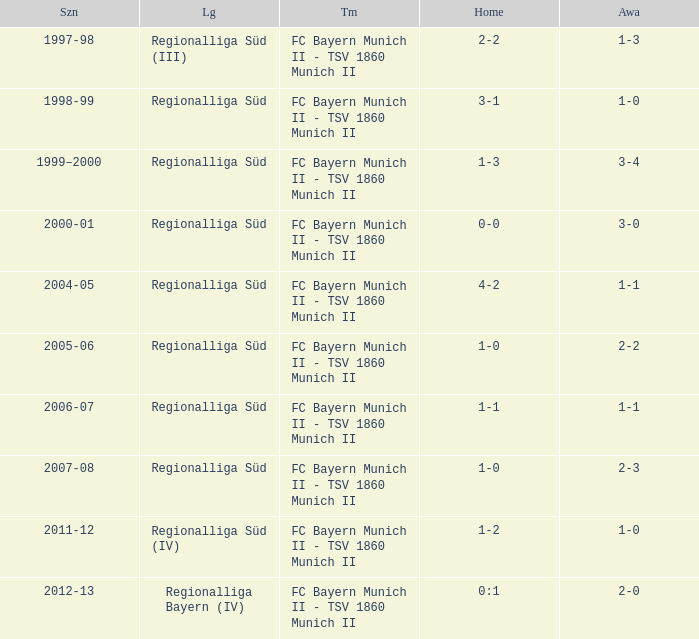What is the league with a 0:1 home? Regionalliga Bayern (IV). 